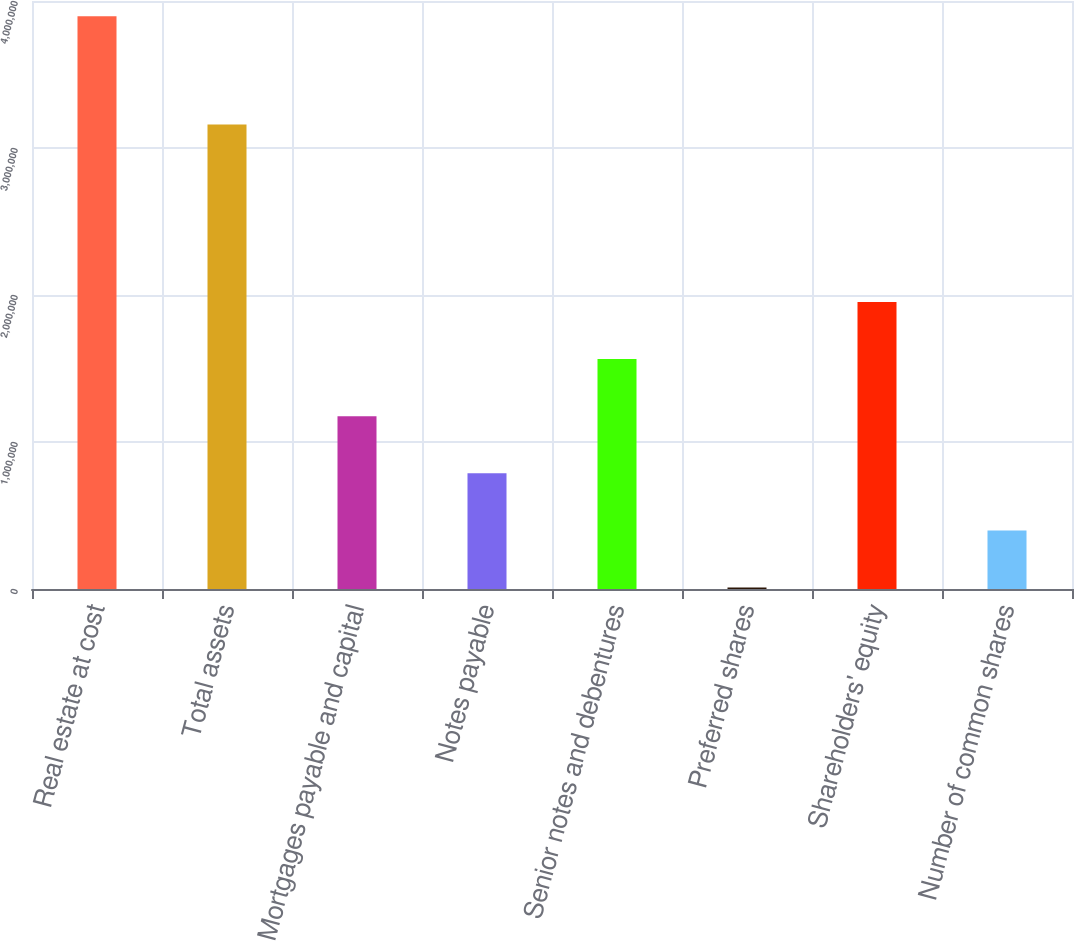Convert chart. <chart><loc_0><loc_0><loc_500><loc_500><bar_chart><fcel>Real estate at cost<fcel>Total assets<fcel>Mortgages payable and capital<fcel>Notes payable<fcel>Senior notes and debentures<fcel>Preferred shares<fcel>Shareholders' equity<fcel>Number of common shares<nl><fcel>3.89594e+06<fcel>3.15955e+06<fcel>1.17578e+06<fcel>787186<fcel>1.56438e+06<fcel>9997<fcel>1.95297e+06<fcel>398592<nl></chart> 